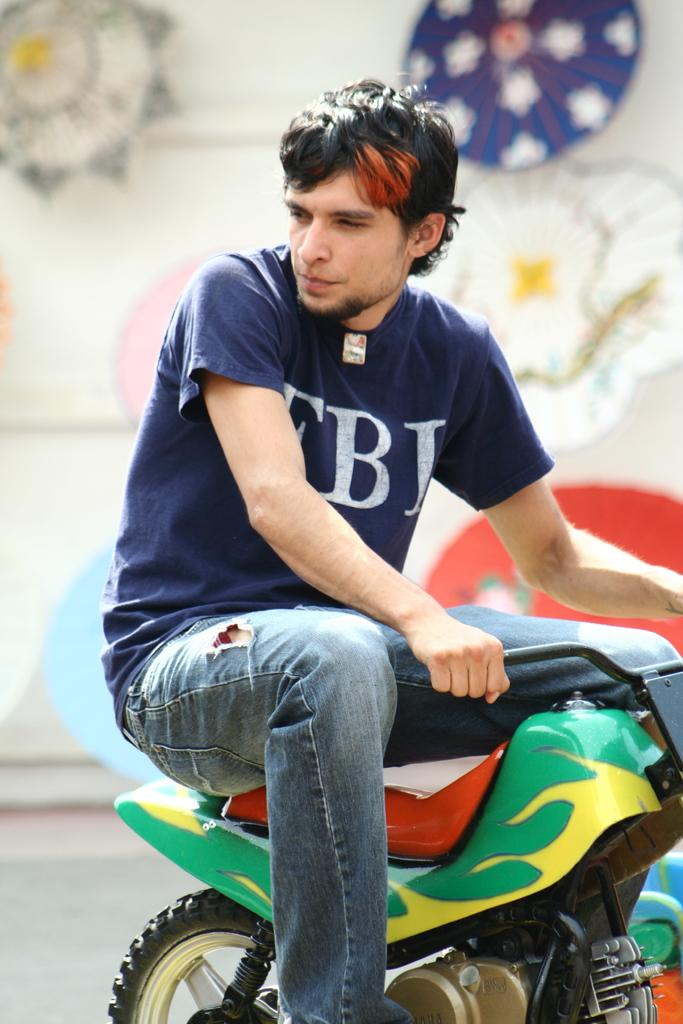Who is present in the image? There is a man in the image. What is the man doing in the image? The man is riding a toy motorcycle. Can you describe the background of the image? The background of the image is blurred. What type of flight can be seen in the image? There is no flight present in the image; it features a man riding a toy motorcycle. What might have surprised the man in the image? There is no indication of surprise in the image, as the man is simply riding a toy motorcycle. 